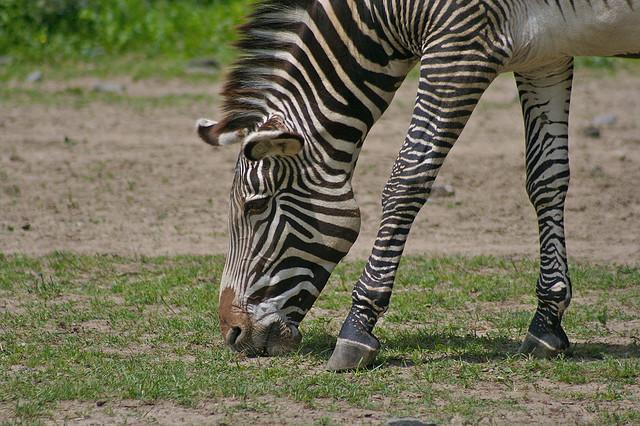How many stripes do you see?
Short answer required. 55. How many hooves are visible?
Concise answer only. 2. Is it standing over a log?
Short answer required. No. What color is the zebra's nose?
Write a very short answer. Brown. How many stripes are on the zebras ears?
Give a very brief answer. 2. Is the animal walking?
Keep it brief. No. Is the zebra eating?
Quick response, please. Yes. What is the zebra eating?
Short answer required. Grass. What is the zebra doing?
Give a very brief answer. Eating. Are there trees in the background?
Write a very short answer. No. How many animals in this photo?
Short answer required. 1. Is the zebra's nose higher than its knees?
Be succinct. No. 